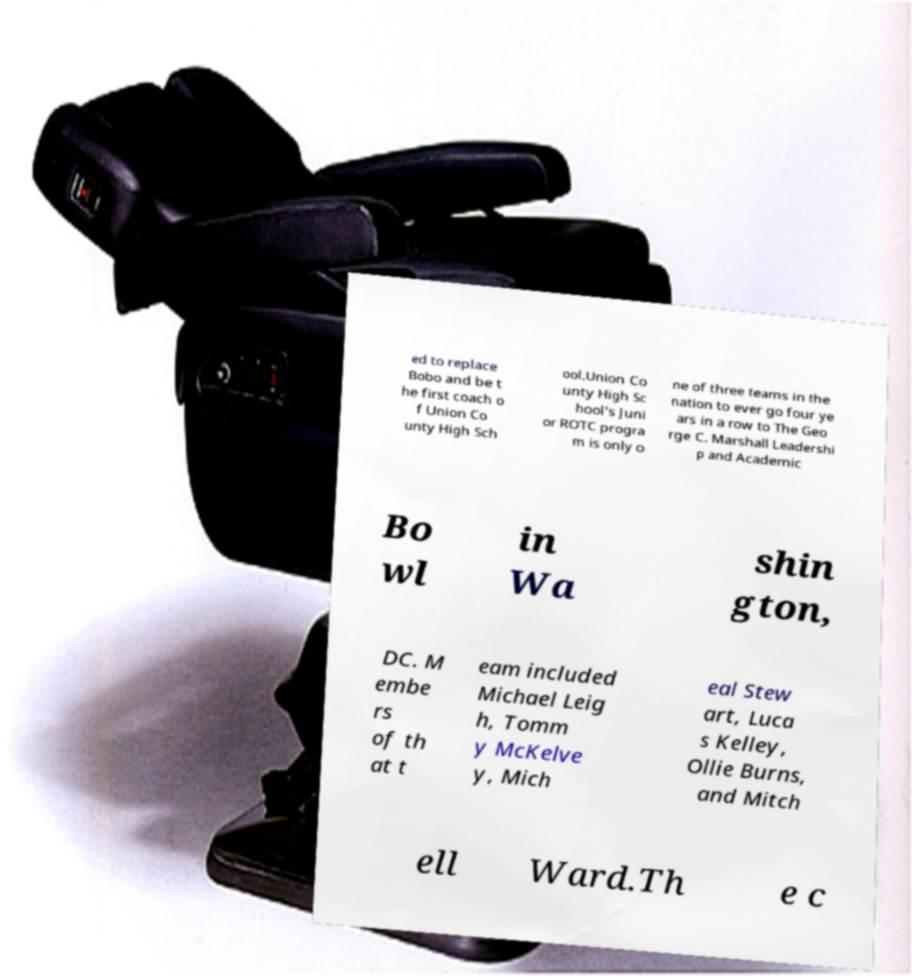I need the written content from this picture converted into text. Can you do that? ed to replace Bobo and be t he first coach o f Union Co unty High Sch ool.Union Co unty High Sc hool's Juni or ROTC progra m is only o ne of three teams in the nation to ever go four ye ars in a row to The Geo rge C. Marshall Leadershi p and Academic Bo wl in Wa shin gton, DC. M embe rs of th at t eam included Michael Leig h, Tomm y McKelve y, Mich eal Stew art, Luca s Kelley, Ollie Burns, and Mitch ell Ward.Th e c 